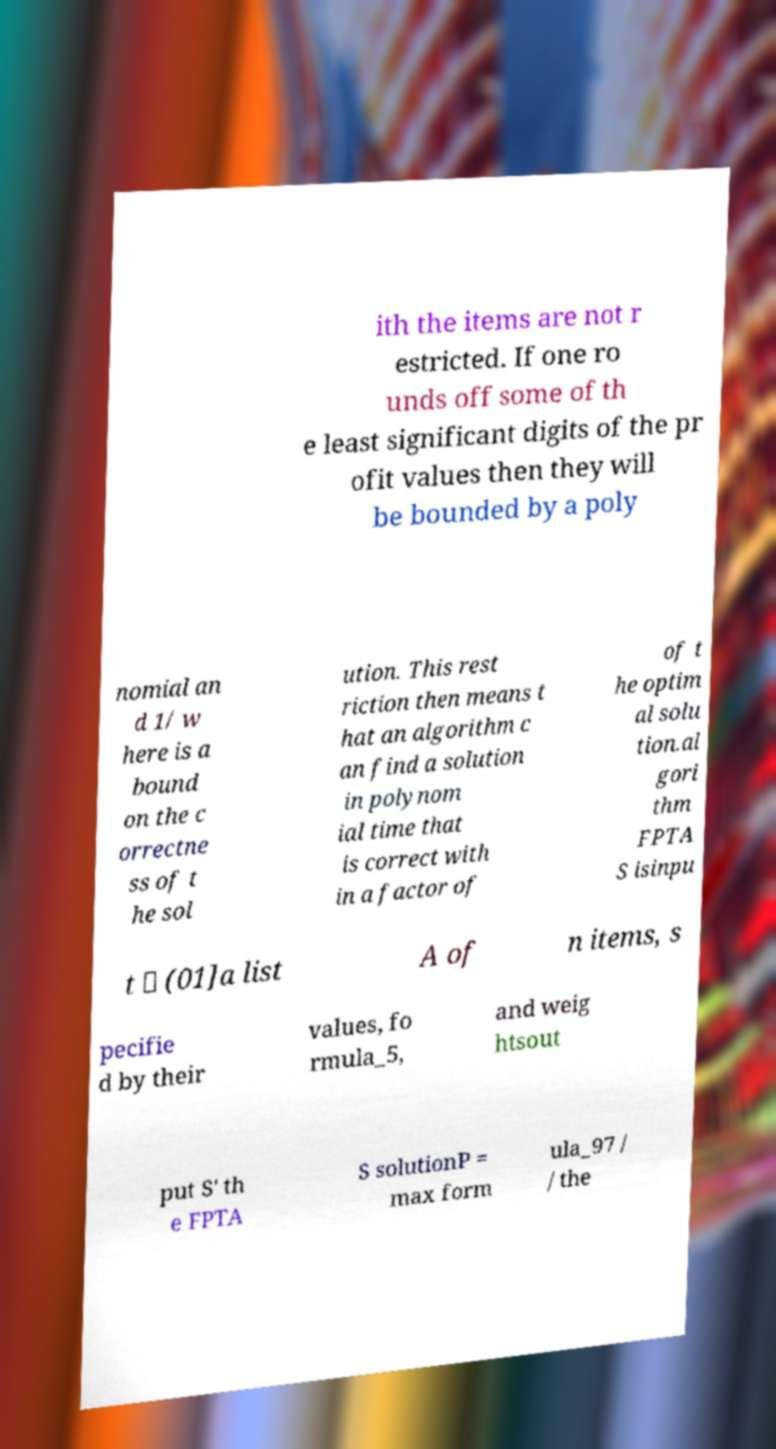What messages or text are displayed in this image? I need them in a readable, typed format. ith the items are not r estricted. If one ro unds off some of th e least significant digits of the pr ofit values then they will be bounded by a poly nomial an d 1/ w here is a bound on the c orrectne ss of t he sol ution. This rest riction then means t hat an algorithm c an find a solution in polynom ial time that is correct with in a factor of of t he optim al solu tion.al gori thm FPTA S isinpu t ∈ (01]a list A of n items, s pecifie d by their values, fo rmula_5, and weig htsout put S' th e FPTA S solutionP = max form ula_97 / / the 